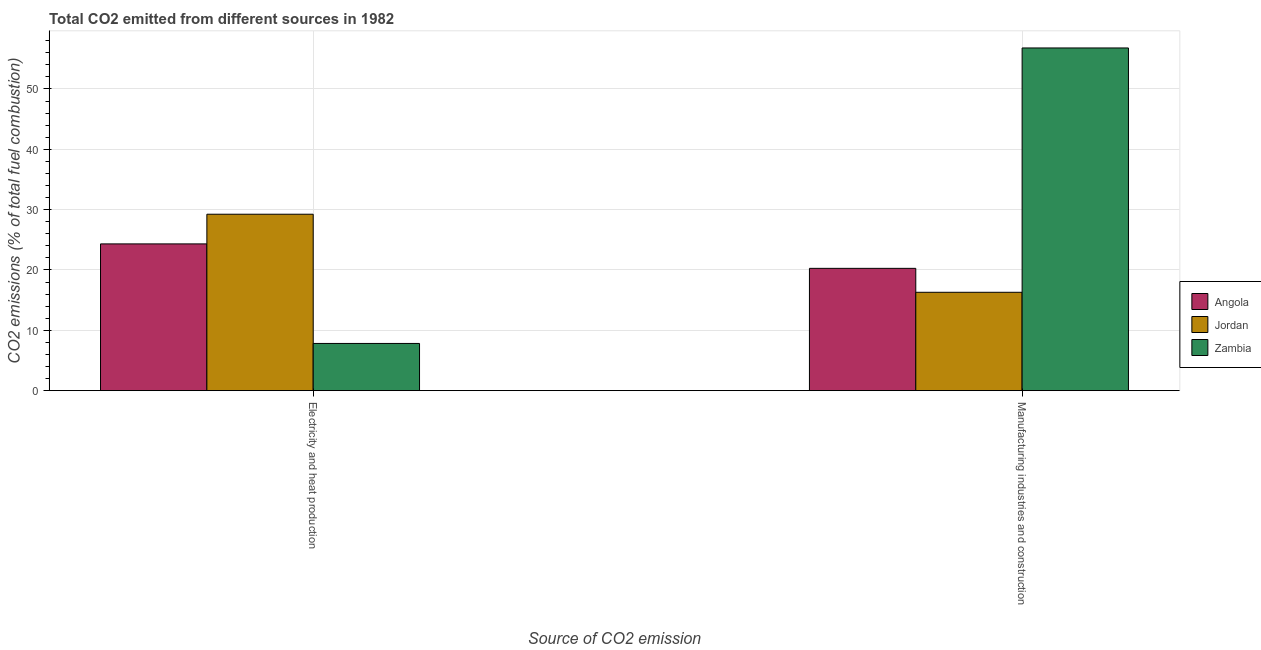Are the number of bars on each tick of the X-axis equal?
Provide a short and direct response. Yes. How many bars are there on the 2nd tick from the left?
Make the answer very short. 3. What is the label of the 1st group of bars from the left?
Provide a short and direct response. Electricity and heat production. What is the co2 emissions due to manufacturing industries in Angola?
Make the answer very short. 20.27. Across all countries, what is the maximum co2 emissions due to electricity and heat production?
Provide a succinct answer. 29.24. Across all countries, what is the minimum co2 emissions due to electricity and heat production?
Ensure brevity in your answer.  7.82. In which country was the co2 emissions due to electricity and heat production maximum?
Provide a short and direct response. Jordan. In which country was the co2 emissions due to manufacturing industries minimum?
Your answer should be compact. Jordan. What is the total co2 emissions due to manufacturing industries in the graph?
Ensure brevity in your answer.  93.38. What is the difference between the co2 emissions due to electricity and heat production in Zambia and that in Jordan?
Provide a succinct answer. -21.42. What is the difference between the co2 emissions due to electricity and heat production in Angola and the co2 emissions due to manufacturing industries in Zambia?
Offer a very short reply. -32.48. What is the average co2 emissions due to electricity and heat production per country?
Your answer should be very brief. 20.46. What is the difference between the co2 emissions due to manufacturing industries and co2 emissions due to electricity and heat production in Jordan?
Offer a terse response. -12.94. In how many countries, is the co2 emissions due to electricity and heat production greater than 26 %?
Give a very brief answer. 1. What is the ratio of the co2 emissions due to electricity and heat production in Jordan to that in Zambia?
Provide a succinct answer. 3.74. What does the 1st bar from the left in Manufacturing industries and construction represents?
Your response must be concise. Angola. What does the 3rd bar from the right in Manufacturing industries and construction represents?
Provide a succinct answer. Angola. How many bars are there?
Offer a terse response. 6. Are all the bars in the graph horizontal?
Provide a short and direct response. No. What is the difference between two consecutive major ticks on the Y-axis?
Make the answer very short. 10. Are the values on the major ticks of Y-axis written in scientific E-notation?
Your answer should be compact. No. Does the graph contain grids?
Offer a very short reply. Yes. Where does the legend appear in the graph?
Your response must be concise. Center right. What is the title of the graph?
Keep it short and to the point. Total CO2 emitted from different sources in 1982. What is the label or title of the X-axis?
Your response must be concise. Source of CO2 emission. What is the label or title of the Y-axis?
Ensure brevity in your answer.  CO2 emissions (% of total fuel combustion). What is the CO2 emissions (% of total fuel combustion) in Angola in Electricity and heat production?
Your answer should be compact. 24.32. What is the CO2 emissions (% of total fuel combustion) in Jordan in Electricity and heat production?
Provide a short and direct response. 29.24. What is the CO2 emissions (% of total fuel combustion) in Zambia in Electricity and heat production?
Your answer should be very brief. 7.82. What is the CO2 emissions (% of total fuel combustion) of Angola in Manufacturing industries and construction?
Your answer should be very brief. 20.27. What is the CO2 emissions (% of total fuel combustion) in Jordan in Manufacturing industries and construction?
Give a very brief answer. 16.3. What is the CO2 emissions (% of total fuel combustion) of Zambia in Manufacturing industries and construction?
Keep it short and to the point. 56.8. Across all Source of CO2 emission, what is the maximum CO2 emissions (% of total fuel combustion) in Angola?
Make the answer very short. 24.32. Across all Source of CO2 emission, what is the maximum CO2 emissions (% of total fuel combustion) of Jordan?
Offer a terse response. 29.24. Across all Source of CO2 emission, what is the maximum CO2 emissions (% of total fuel combustion) of Zambia?
Ensure brevity in your answer.  56.8. Across all Source of CO2 emission, what is the minimum CO2 emissions (% of total fuel combustion) in Angola?
Offer a terse response. 20.27. Across all Source of CO2 emission, what is the minimum CO2 emissions (% of total fuel combustion) in Jordan?
Provide a succinct answer. 16.3. Across all Source of CO2 emission, what is the minimum CO2 emissions (% of total fuel combustion) in Zambia?
Your answer should be compact. 7.82. What is the total CO2 emissions (% of total fuel combustion) in Angola in the graph?
Offer a terse response. 44.59. What is the total CO2 emissions (% of total fuel combustion) of Jordan in the graph?
Your response must be concise. 45.55. What is the total CO2 emissions (% of total fuel combustion) of Zambia in the graph?
Make the answer very short. 64.63. What is the difference between the CO2 emissions (% of total fuel combustion) of Angola in Electricity and heat production and that in Manufacturing industries and construction?
Your response must be concise. 4.05. What is the difference between the CO2 emissions (% of total fuel combustion) in Jordan in Electricity and heat production and that in Manufacturing industries and construction?
Your answer should be very brief. 12.94. What is the difference between the CO2 emissions (% of total fuel combustion) in Zambia in Electricity and heat production and that in Manufacturing industries and construction?
Offer a terse response. -48.98. What is the difference between the CO2 emissions (% of total fuel combustion) in Angola in Electricity and heat production and the CO2 emissions (% of total fuel combustion) in Jordan in Manufacturing industries and construction?
Offer a terse response. 8.02. What is the difference between the CO2 emissions (% of total fuel combustion) of Angola in Electricity and heat production and the CO2 emissions (% of total fuel combustion) of Zambia in Manufacturing industries and construction?
Offer a terse response. -32.48. What is the difference between the CO2 emissions (% of total fuel combustion) of Jordan in Electricity and heat production and the CO2 emissions (% of total fuel combustion) of Zambia in Manufacturing industries and construction?
Give a very brief answer. -27.56. What is the average CO2 emissions (% of total fuel combustion) in Angola per Source of CO2 emission?
Give a very brief answer. 22.3. What is the average CO2 emissions (% of total fuel combustion) of Jordan per Source of CO2 emission?
Provide a succinct answer. 22.77. What is the average CO2 emissions (% of total fuel combustion) of Zambia per Source of CO2 emission?
Ensure brevity in your answer.  32.31. What is the difference between the CO2 emissions (% of total fuel combustion) in Angola and CO2 emissions (% of total fuel combustion) in Jordan in Electricity and heat production?
Provide a short and direct response. -4.92. What is the difference between the CO2 emissions (% of total fuel combustion) in Angola and CO2 emissions (% of total fuel combustion) in Zambia in Electricity and heat production?
Provide a short and direct response. 16.5. What is the difference between the CO2 emissions (% of total fuel combustion) of Jordan and CO2 emissions (% of total fuel combustion) of Zambia in Electricity and heat production?
Offer a terse response. 21.42. What is the difference between the CO2 emissions (% of total fuel combustion) of Angola and CO2 emissions (% of total fuel combustion) of Jordan in Manufacturing industries and construction?
Keep it short and to the point. 3.97. What is the difference between the CO2 emissions (% of total fuel combustion) of Angola and CO2 emissions (% of total fuel combustion) of Zambia in Manufacturing industries and construction?
Make the answer very short. -36.53. What is the difference between the CO2 emissions (% of total fuel combustion) in Jordan and CO2 emissions (% of total fuel combustion) in Zambia in Manufacturing industries and construction?
Make the answer very short. -40.5. What is the ratio of the CO2 emissions (% of total fuel combustion) of Angola in Electricity and heat production to that in Manufacturing industries and construction?
Ensure brevity in your answer.  1.2. What is the ratio of the CO2 emissions (% of total fuel combustion) in Jordan in Electricity and heat production to that in Manufacturing industries and construction?
Provide a short and direct response. 1.79. What is the ratio of the CO2 emissions (% of total fuel combustion) of Zambia in Electricity and heat production to that in Manufacturing industries and construction?
Give a very brief answer. 0.14. What is the difference between the highest and the second highest CO2 emissions (% of total fuel combustion) of Angola?
Your answer should be compact. 4.05. What is the difference between the highest and the second highest CO2 emissions (% of total fuel combustion) of Jordan?
Your response must be concise. 12.94. What is the difference between the highest and the second highest CO2 emissions (% of total fuel combustion) of Zambia?
Offer a terse response. 48.98. What is the difference between the highest and the lowest CO2 emissions (% of total fuel combustion) of Angola?
Your answer should be very brief. 4.05. What is the difference between the highest and the lowest CO2 emissions (% of total fuel combustion) of Jordan?
Offer a terse response. 12.94. What is the difference between the highest and the lowest CO2 emissions (% of total fuel combustion) of Zambia?
Your answer should be compact. 48.98. 